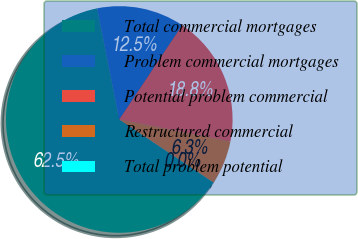<chart> <loc_0><loc_0><loc_500><loc_500><pie_chart><fcel>Total commercial mortgages<fcel>Problem commercial mortgages<fcel>Potential problem commercial<fcel>Restructured commercial<fcel>Total problem potential<nl><fcel>62.48%<fcel>12.5%<fcel>18.75%<fcel>6.26%<fcel>0.01%<nl></chart> 